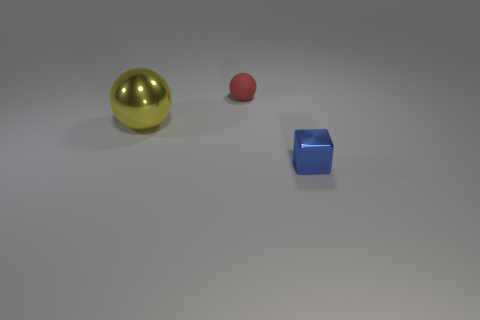How many objects are either small blue objects right of the yellow metallic thing or small things that are in front of the large metal thing?
Provide a short and direct response. 1. Are there fewer red objects than large purple metallic objects?
Give a very brief answer. No. What shape is the metallic thing that is the same size as the red rubber object?
Make the answer very short. Cube. What number of big blue objects are there?
Your answer should be compact. 0. How many balls are both right of the big yellow thing and in front of the red matte object?
Provide a succinct answer. 0. What is the red thing made of?
Make the answer very short. Rubber. Is there a big yellow ball?
Your response must be concise. Yes. There is a tiny block on the right side of the red thing; what is its color?
Your answer should be very brief. Blue. How many small red objects are behind the small thing behind the shiny thing that is right of the yellow sphere?
Offer a very short reply. 0. What is the thing that is both right of the large metallic ball and in front of the small ball made of?
Ensure brevity in your answer.  Metal. 